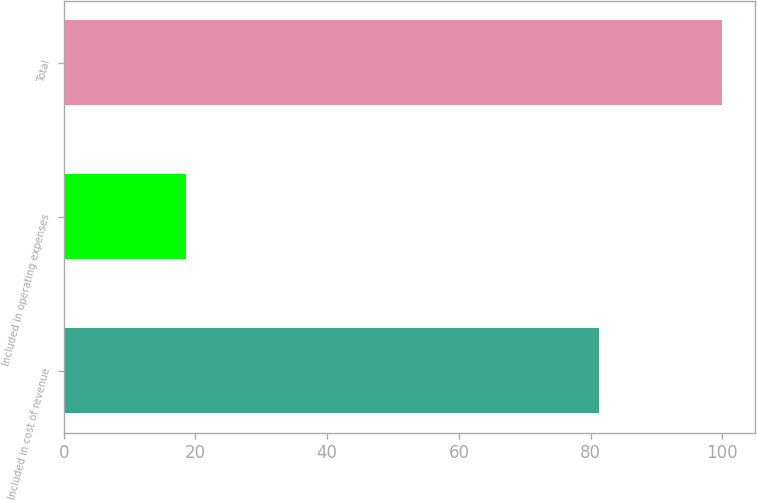Convert chart. <chart><loc_0><loc_0><loc_500><loc_500><bar_chart><fcel>Included in cost of revenue<fcel>Included in operating expenses<fcel>Total<nl><fcel>81.3<fcel>18.6<fcel>99.9<nl></chart> 